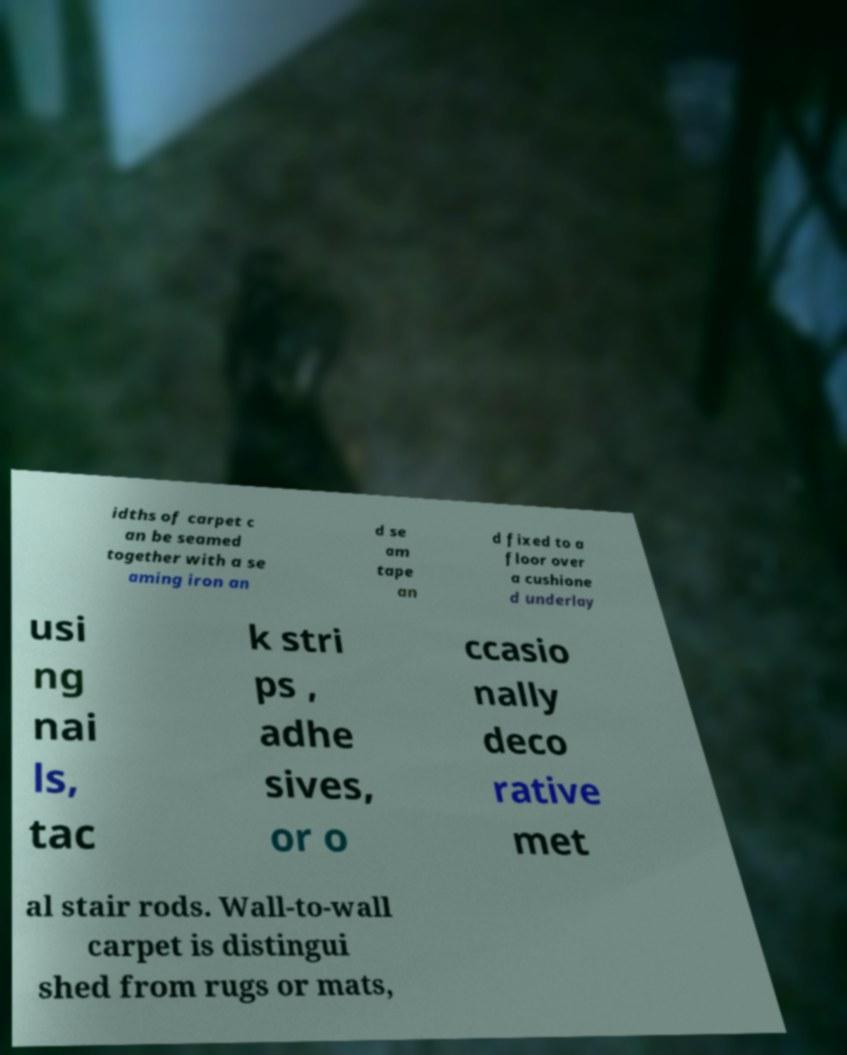There's text embedded in this image that I need extracted. Can you transcribe it verbatim? idths of carpet c an be seamed together with a se aming iron an d se am tape an d fixed to a floor over a cushione d underlay usi ng nai ls, tac k stri ps , adhe sives, or o ccasio nally deco rative met al stair rods. Wall-to-wall carpet is distingui shed from rugs or mats, 